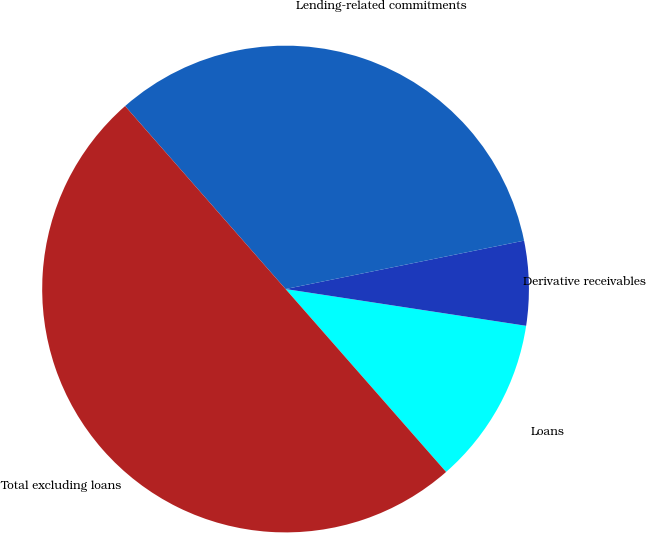Convert chart to OTSL. <chart><loc_0><loc_0><loc_500><loc_500><pie_chart><fcel>Loans<fcel>Derivative receivables<fcel>Lending-related commitments<fcel>Total excluding loans<nl><fcel>11.12%<fcel>5.6%<fcel>33.27%<fcel>50.0%<nl></chart> 